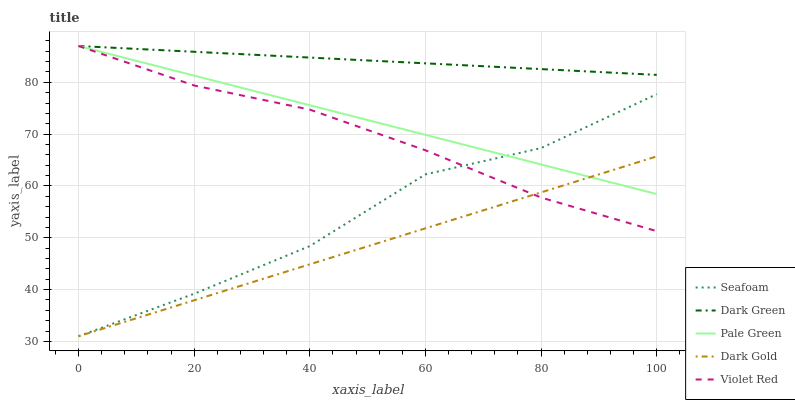Does Dark Gold have the minimum area under the curve?
Answer yes or no. Yes. Does Dark Green have the maximum area under the curve?
Answer yes or no. Yes. Does Pale Green have the minimum area under the curve?
Answer yes or no. No. Does Pale Green have the maximum area under the curve?
Answer yes or no. No. Is Dark Gold the smoothest?
Answer yes or no. Yes. Is Seafoam the roughest?
Answer yes or no. Yes. Is Pale Green the smoothest?
Answer yes or no. No. Is Pale Green the roughest?
Answer yes or no. No. Does Seafoam have the lowest value?
Answer yes or no. Yes. Does Pale Green have the lowest value?
Answer yes or no. No. Does Dark Green have the highest value?
Answer yes or no. Yes. Does Seafoam have the highest value?
Answer yes or no. No. Is Dark Gold less than Dark Green?
Answer yes or no. Yes. Is Dark Green greater than Dark Gold?
Answer yes or no. Yes. Does Pale Green intersect Dark Green?
Answer yes or no. Yes. Is Pale Green less than Dark Green?
Answer yes or no. No. Is Pale Green greater than Dark Green?
Answer yes or no. No. Does Dark Gold intersect Dark Green?
Answer yes or no. No. 